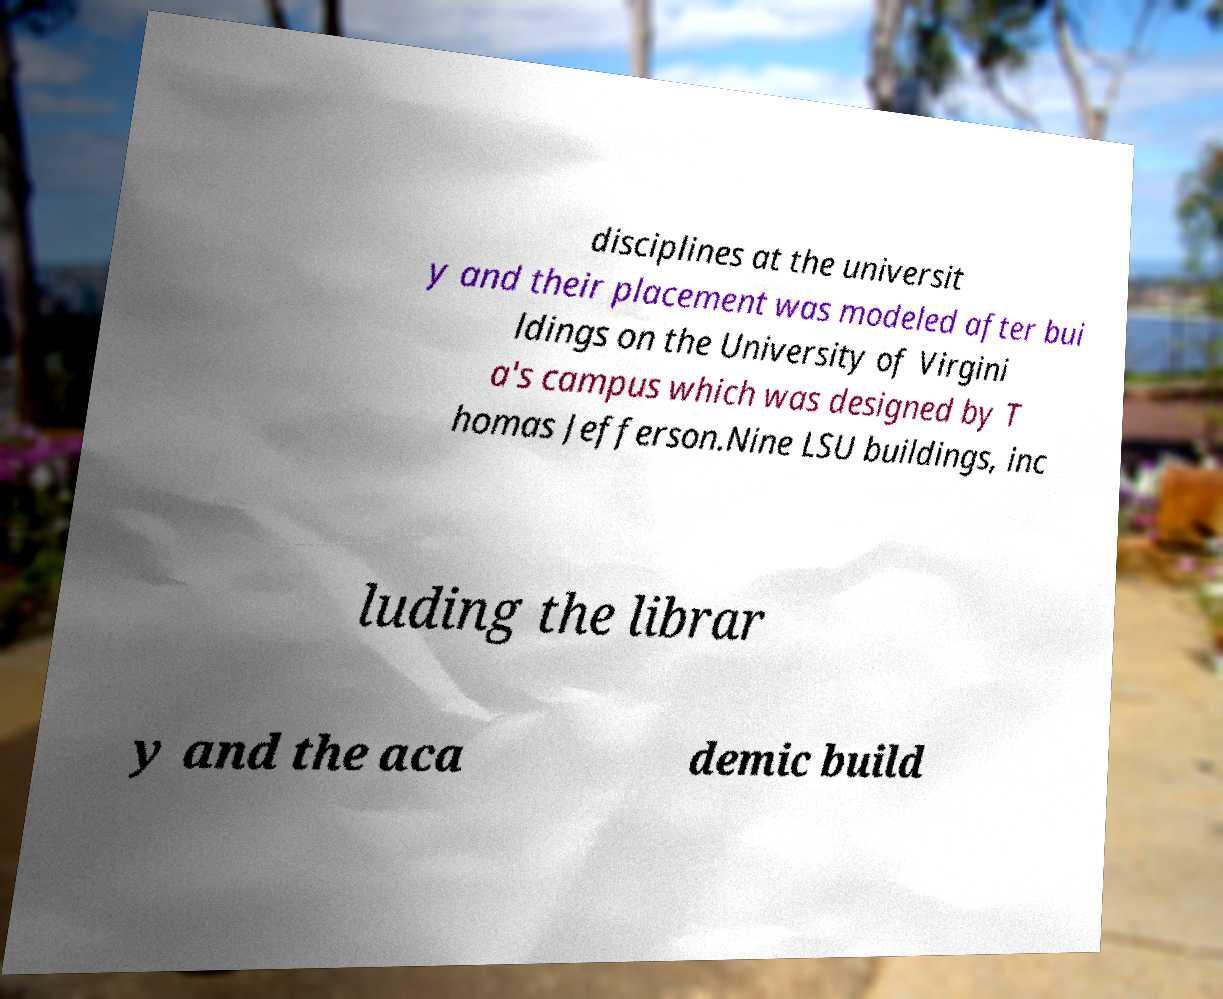Could you assist in decoding the text presented in this image and type it out clearly? disciplines at the universit y and their placement was modeled after bui ldings on the University of Virgini a's campus which was designed by T homas Jefferson.Nine LSU buildings, inc luding the librar y and the aca demic build 